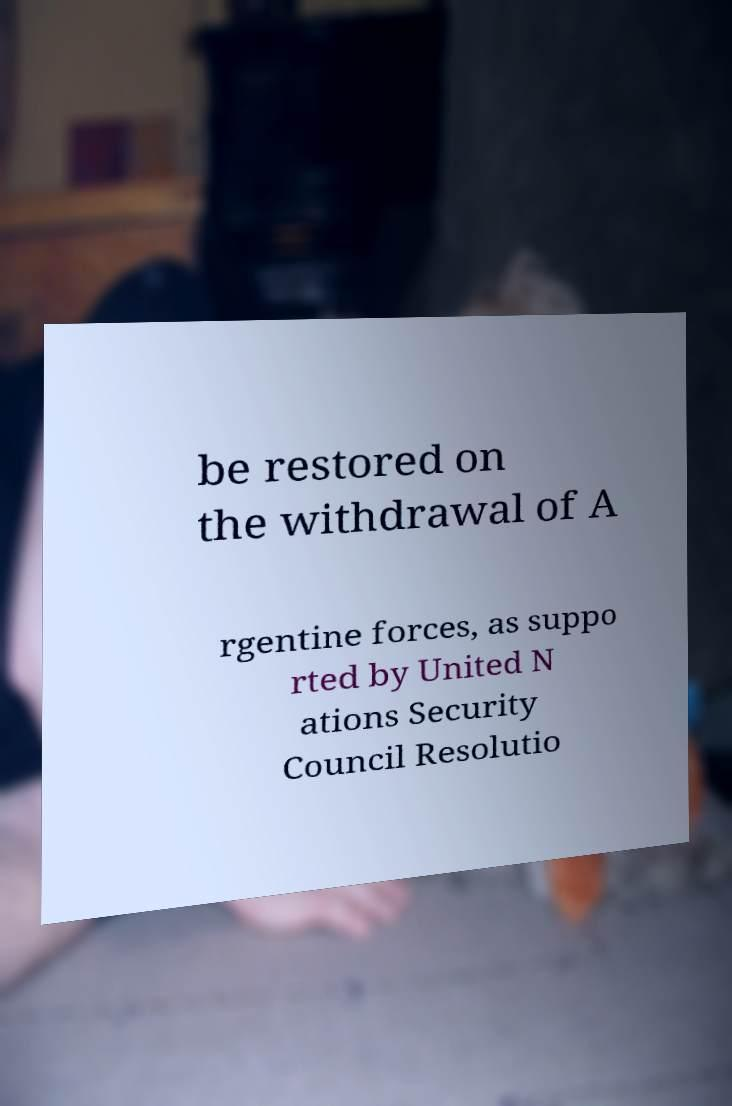Can you accurately transcribe the text from the provided image for me? be restored on the withdrawal of A rgentine forces, as suppo rted by United N ations Security Council Resolutio 